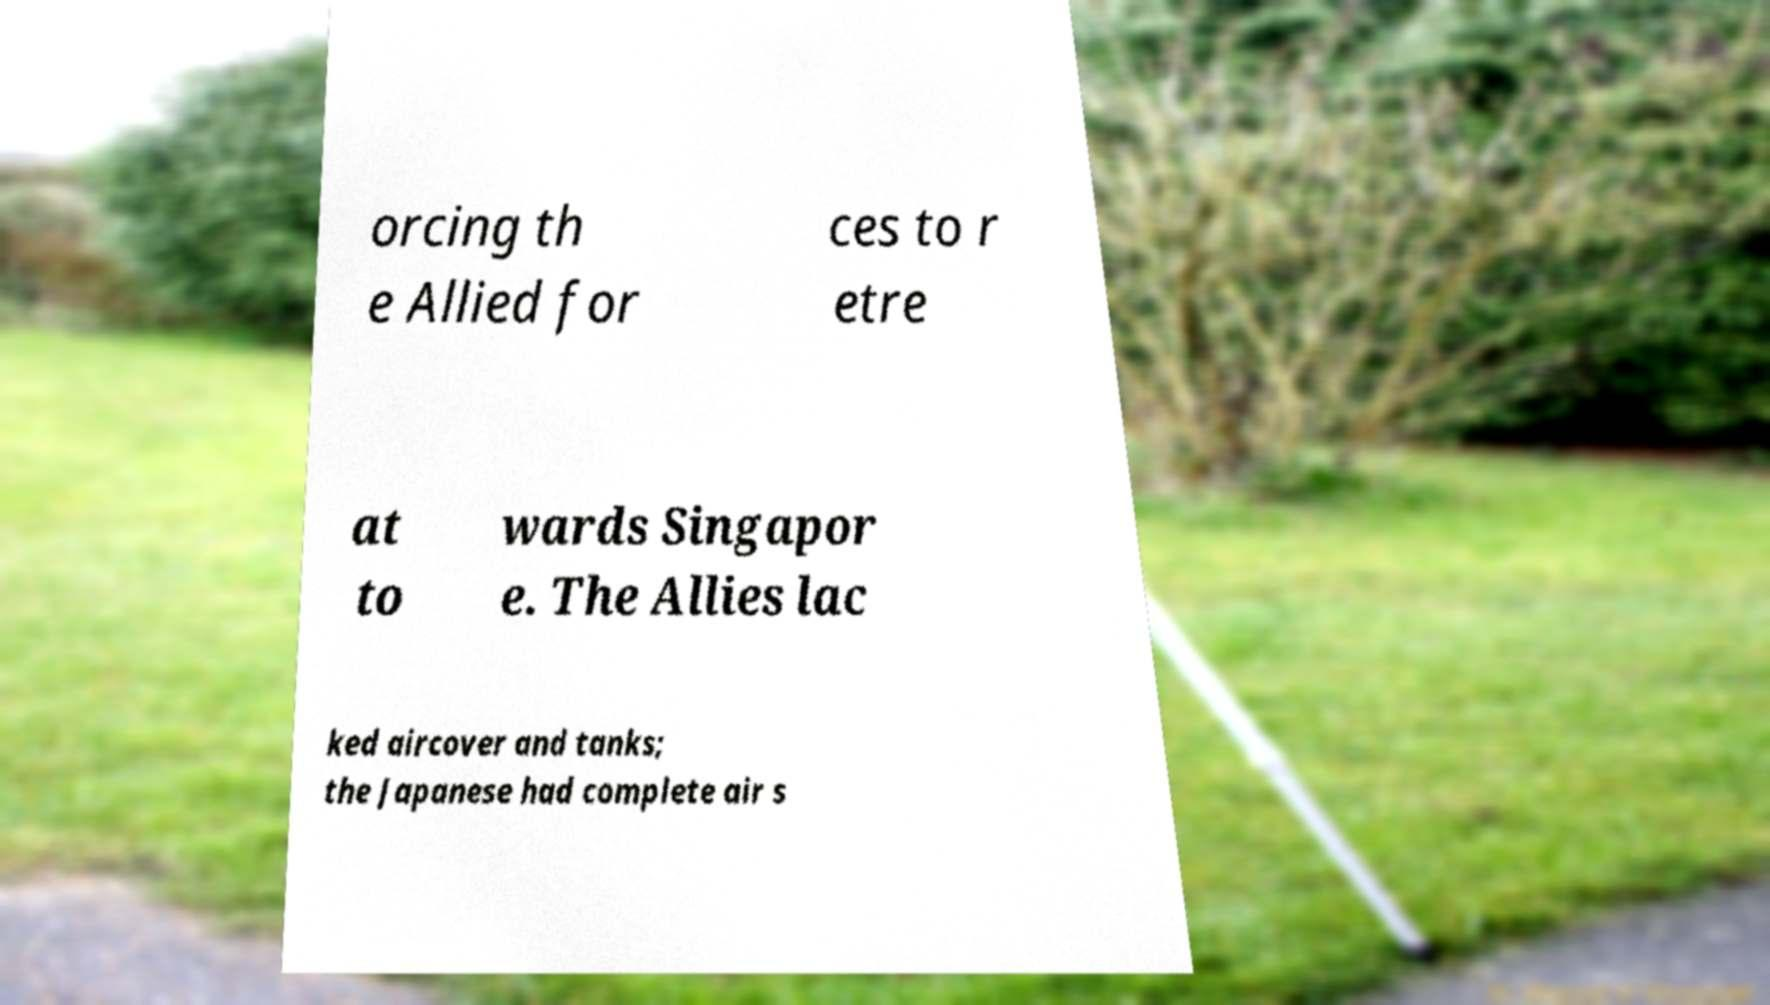Can you accurately transcribe the text from the provided image for me? orcing th e Allied for ces to r etre at to wards Singapor e. The Allies lac ked aircover and tanks; the Japanese had complete air s 